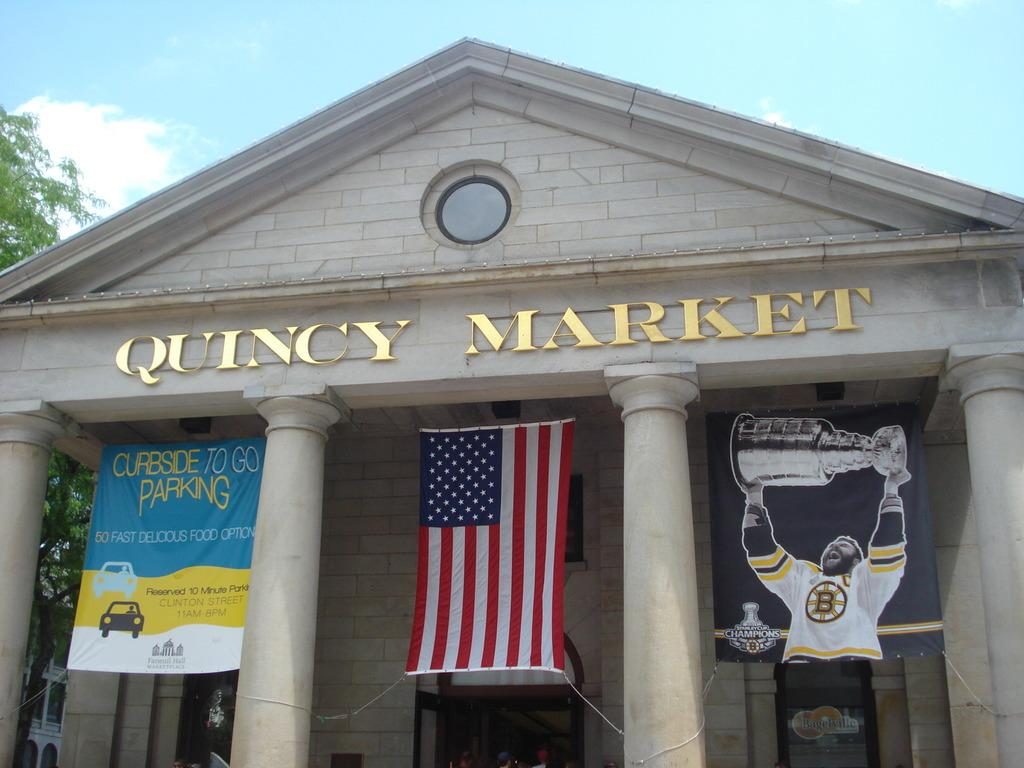Provide a one-sentence caption for the provided image. Banners and the American flag hang between the columns of Quincy Market. 